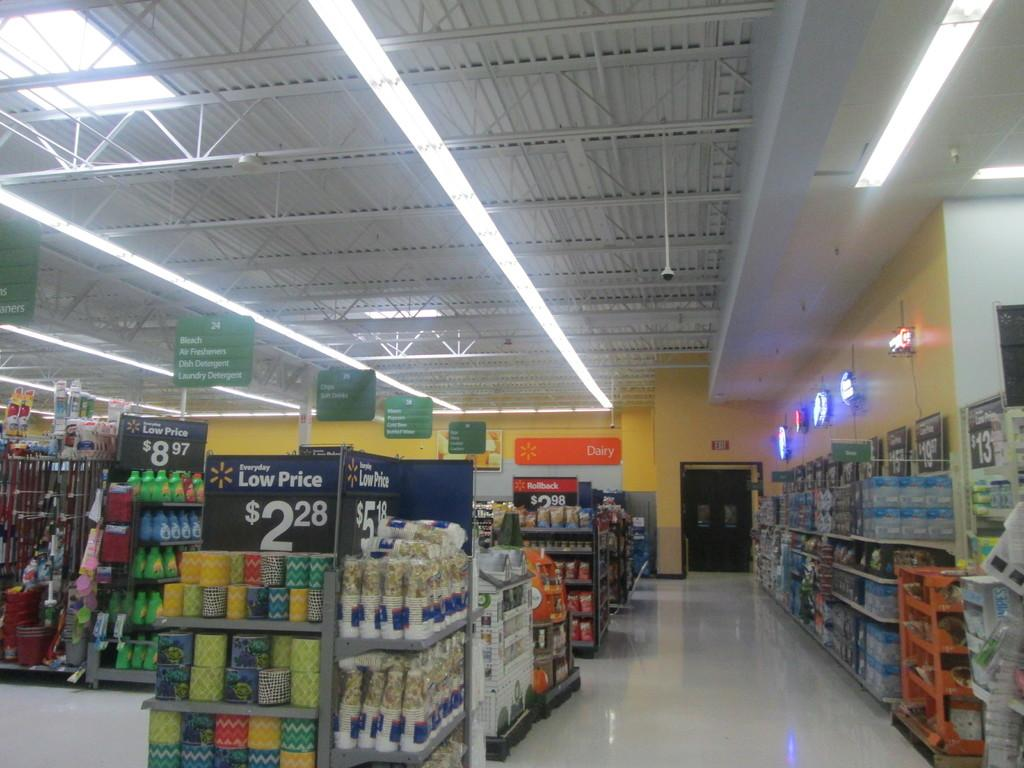<image>
Summarize the visual content of the image. A grocery store isle advertising a low price of 2,28 